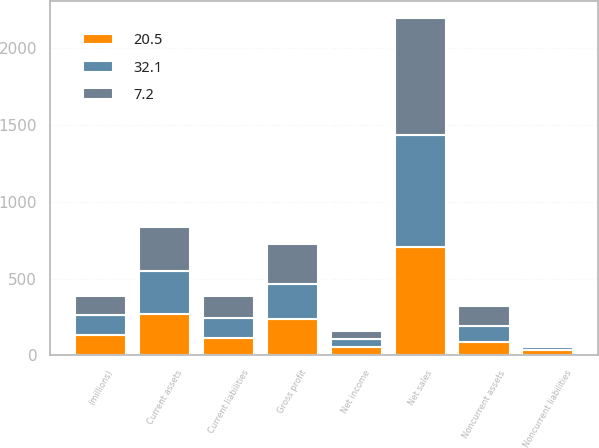Convert chart to OTSL. <chart><loc_0><loc_0><loc_500><loc_500><stacked_bar_chart><ecel><fcel>(millions)<fcel>Net sales<fcel>Gross profit<fcel>Net income<fcel>Current assets<fcel>Noncurrent assets<fcel>Current liabilities<fcel>Noncurrent liabilities<nl><fcel>7.2<fcel>129.9<fcel>761.4<fcel>256.9<fcel>53.8<fcel>288.9<fcel>128.4<fcel>141<fcel>7.2<nl><fcel>32.1<fcel>129.9<fcel>727.1<fcel>229.2<fcel>47.1<fcel>274.4<fcel>104.2<fcel>129.9<fcel>20.5<nl><fcel>20.5<fcel>129.9<fcel>708.5<fcel>238.7<fcel>57.2<fcel>272<fcel>86.5<fcel>113.2<fcel>32.1<nl></chart> 